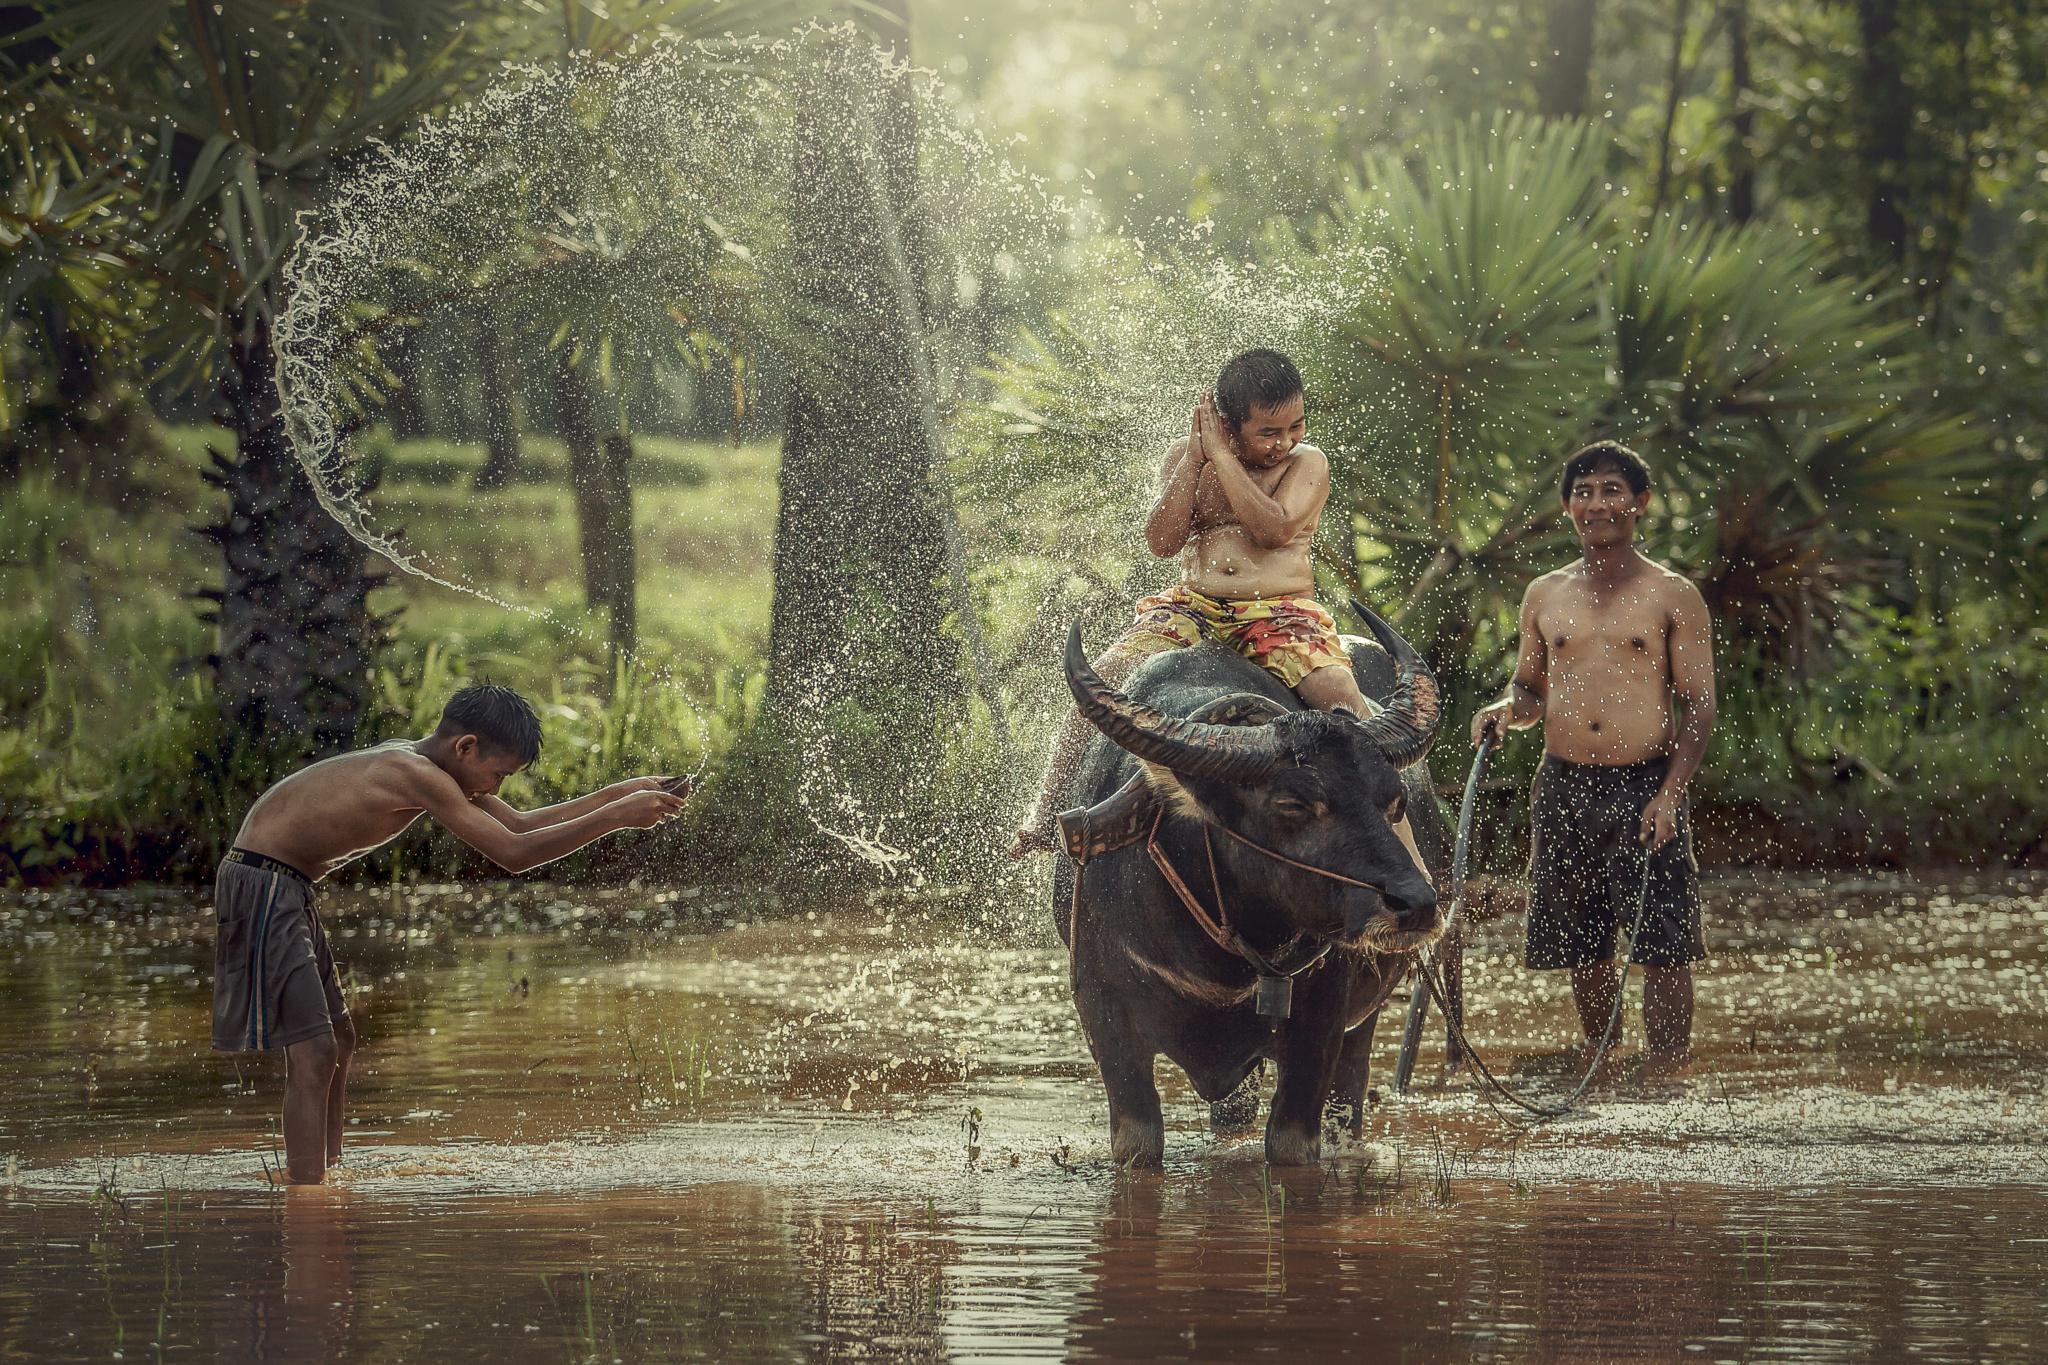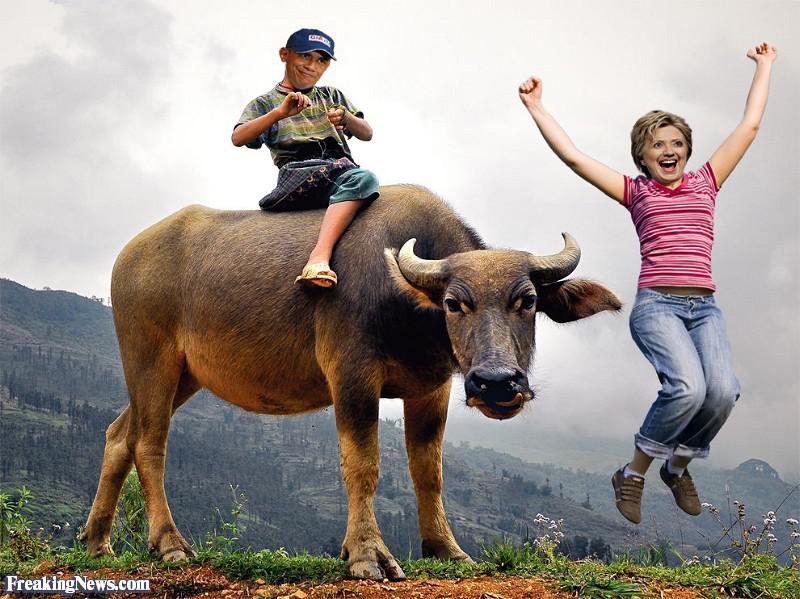The first image is the image on the left, the second image is the image on the right. Given the left and right images, does the statement "In at least one image there are three males with short black hair and at least one male is riding an ox." hold true? Answer yes or no. Yes. The first image is the image on the left, the second image is the image on the right. Given the left and right images, does the statement "The right image shows a child straddling the back of a right-facing water buffalo, and the left image shows a boy holding a stick extended forward while on the back of a water buffalo." hold true? Answer yes or no. No. 